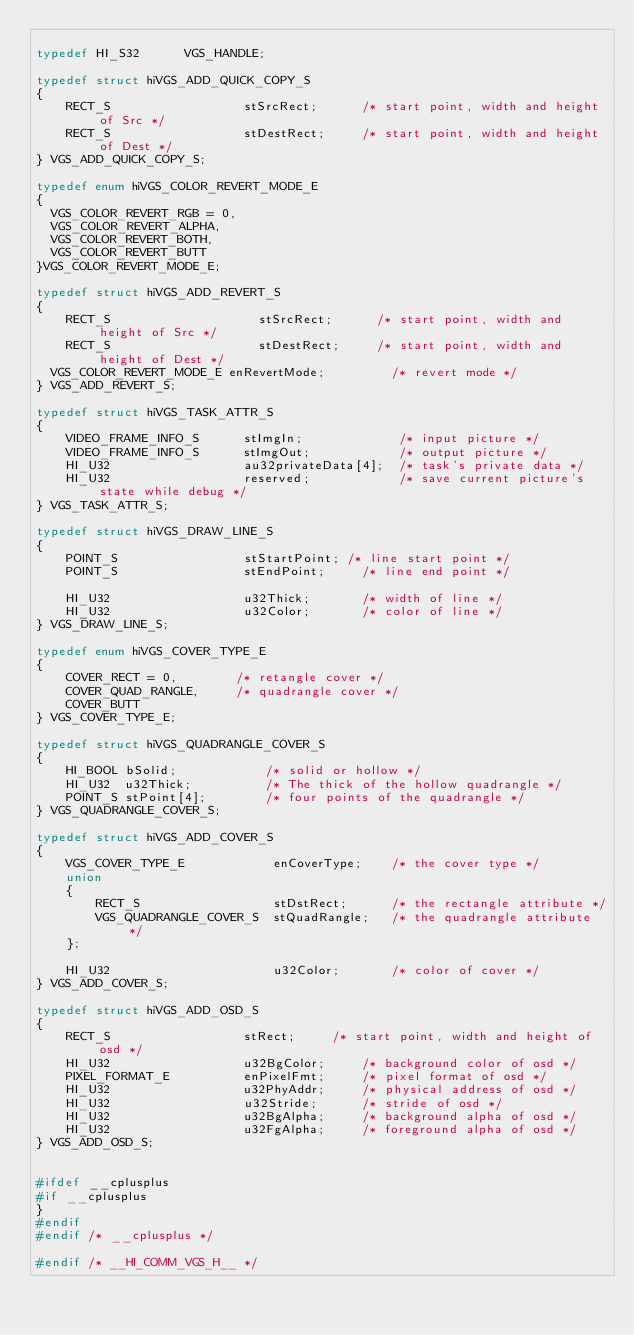<code> <loc_0><loc_0><loc_500><loc_500><_C_>
typedef HI_S32      VGS_HANDLE;

typedef struct hiVGS_ADD_QUICK_COPY_S
{
    RECT_S                  stSrcRect;			/* start point, width and height of Src */
    RECT_S                  stDestRect;			/* start point, width and height of Dest */
} VGS_ADD_QUICK_COPY_S;

typedef enum hiVGS_COLOR_REVERT_MODE_E
{
	VGS_COLOR_REVERT_RGB = 0,
	VGS_COLOR_REVERT_ALPHA,
	VGS_COLOR_REVERT_BOTH,
	VGS_COLOR_REVERT_BUTT
}VGS_COLOR_REVERT_MODE_E;

typedef struct hiVGS_ADD_REVERT_S
{
    RECT_S                    stSrcRect;			/* start point, width and height of Src */
    RECT_S                    stDestRect;			/* start point, width and height of Dest */
	VGS_COLOR_REVERT_MODE_E enRevertMode;         /* revert mode */
} VGS_ADD_REVERT_S;

typedef struct hiVGS_TASK_ATTR_S
{
    VIDEO_FRAME_INFO_S      stImgIn;             /* input picture */
    VIDEO_FRAME_INFO_S      stImgOut;            /* output picture */
    HI_U32                  au32privateData[4];  /* task's private data */
    HI_U32                  reserved;            /* save current picture's state while debug */
} VGS_TASK_ATTR_S;

typedef struct hiVGS_DRAW_LINE_S
{
    POINT_S                 stStartPoint;	/* line start point */
    POINT_S                 stEndPoint;     /* line end point */

    HI_U32                  u32Thick;       /* width of line */
    HI_U32                  u32Color;       /* color of line */
} VGS_DRAW_LINE_S;

typedef enum hiVGS_COVER_TYPE_E
{
    COVER_RECT = 0,        /* retangle cover */
    COVER_QUAD_RANGLE,     /* quadrangle cover */
    COVER_BUTT
} VGS_COVER_TYPE_E;

typedef struct hiVGS_QUADRANGLE_COVER_S
{
    HI_BOOL bSolid;            /* solid or hollow */
    HI_U32  u32Thick;          /* The thick of the hollow quadrangle */
    POINT_S stPoint[4];        /* four points of the quadrangle */
} VGS_QUADRANGLE_COVER_S;

typedef struct hiVGS_ADD_COVER_S
{
    VGS_COVER_TYPE_E            enCoverType;    /* the cover type */
    union
    {
        RECT_S                  stDstRect;      /* the rectangle attribute */
        VGS_QUADRANGLE_COVER_S  stQuadRangle;   /* the quadrangle attribute */
    };

    HI_U32                      u32Color;       /* color of cover */
} VGS_ADD_COVER_S;

typedef struct hiVGS_ADD_OSD_S
{
    RECT_S                  stRect;			/* start point, width and height of osd */
    HI_U32                  u32BgColor;     /* background color of osd */
    PIXEL_FORMAT_E          enPixelFmt;     /* pixel format of osd */
    HI_U32                  u32PhyAddr;     /* physical address of osd */
    HI_U32                  u32Stride;      /* stride of osd */
    HI_U32                  u32BgAlpha;     /* background alpha of osd */
    HI_U32                  u32FgAlpha;     /* foreground alpha of osd */
} VGS_ADD_OSD_S;


#ifdef __cplusplus
#if __cplusplus
}
#endif
#endif /* __cplusplus */

#endif /* __HI_COMM_VGS_H__ */
</code> 